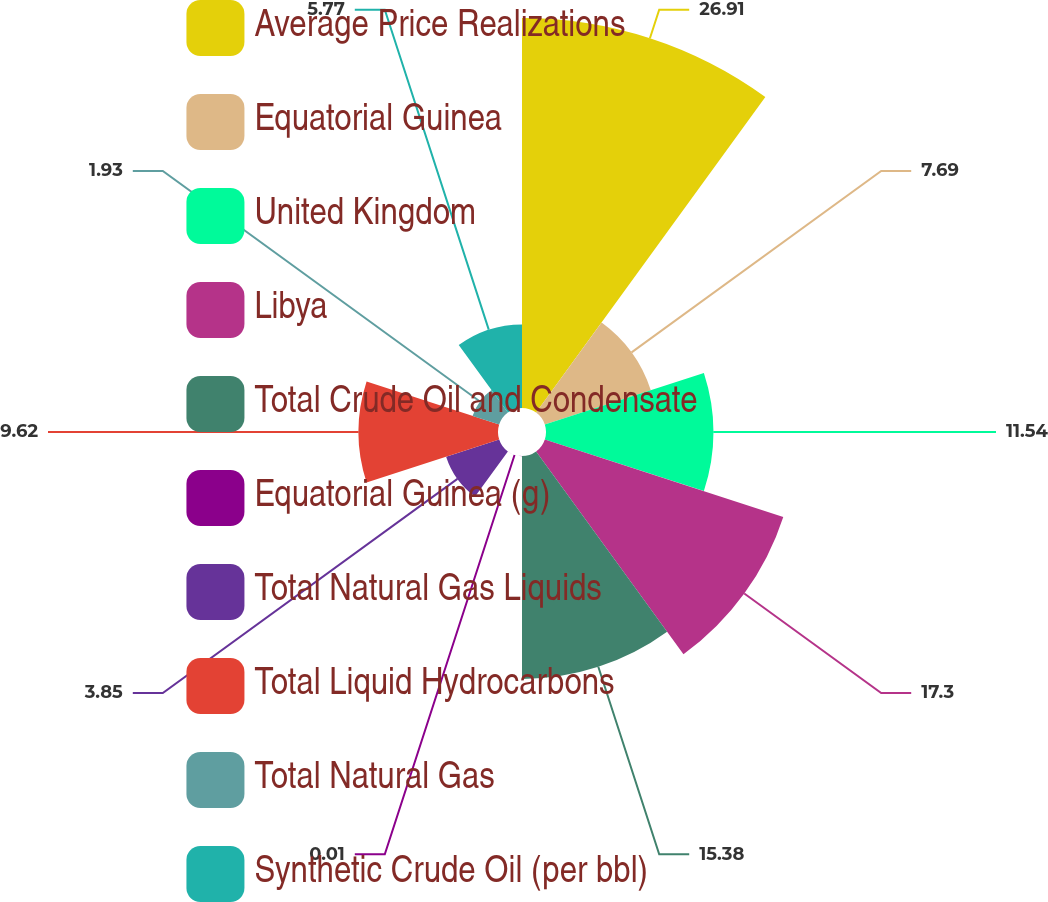<chart> <loc_0><loc_0><loc_500><loc_500><pie_chart><fcel>Average Price Realizations<fcel>Equatorial Guinea<fcel>United Kingdom<fcel>Libya<fcel>Total Crude Oil and Condensate<fcel>Equatorial Guinea (g)<fcel>Total Natural Gas Liquids<fcel>Total Liquid Hydrocarbons<fcel>Total Natural Gas<fcel>Synthetic Crude Oil (per bbl)<nl><fcel>26.91%<fcel>7.69%<fcel>11.54%<fcel>17.3%<fcel>15.38%<fcel>0.01%<fcel>3.85%<fcel>9.62%<fcel>1.93%<fcel>5.77%<nl></chart> 